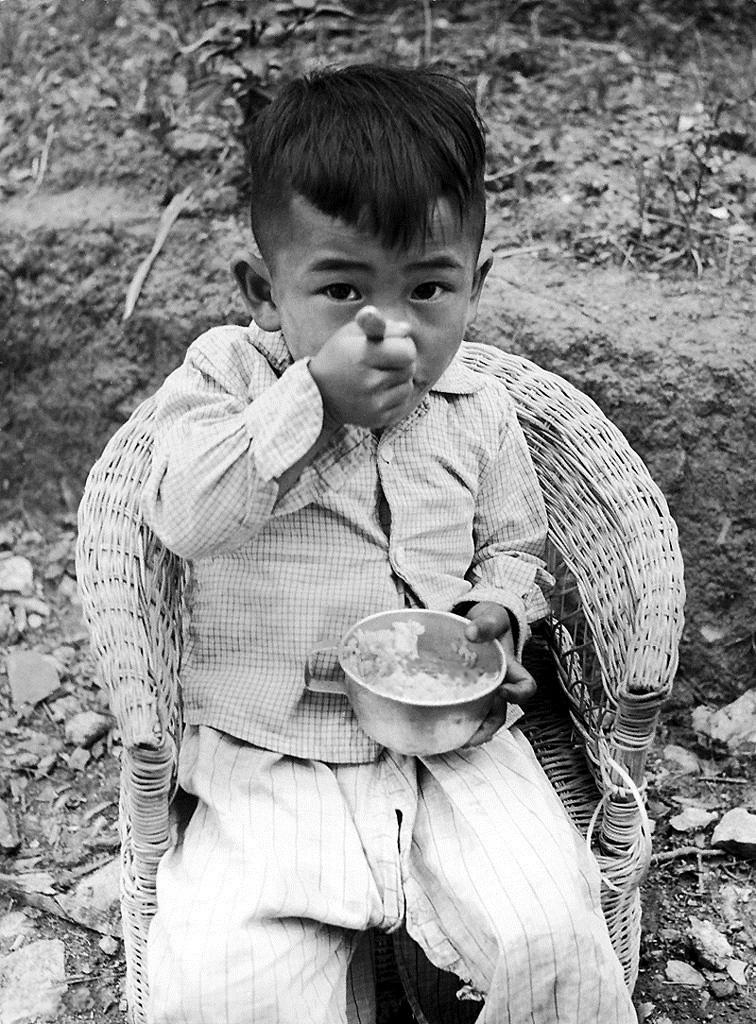What is the color scheme of the image? The image is black and white. Who is present in the image? There is a boy in the image. What is the boy doing in the image? The boy is sitting on a chair and eating. What can be seen on the ground in the image? There are rocks on the ground in the image. What type of wax can be seen being mined by the boy in the image? There is no wax or mining activity present in the image; it features a boy sitting on a chair and eating. 